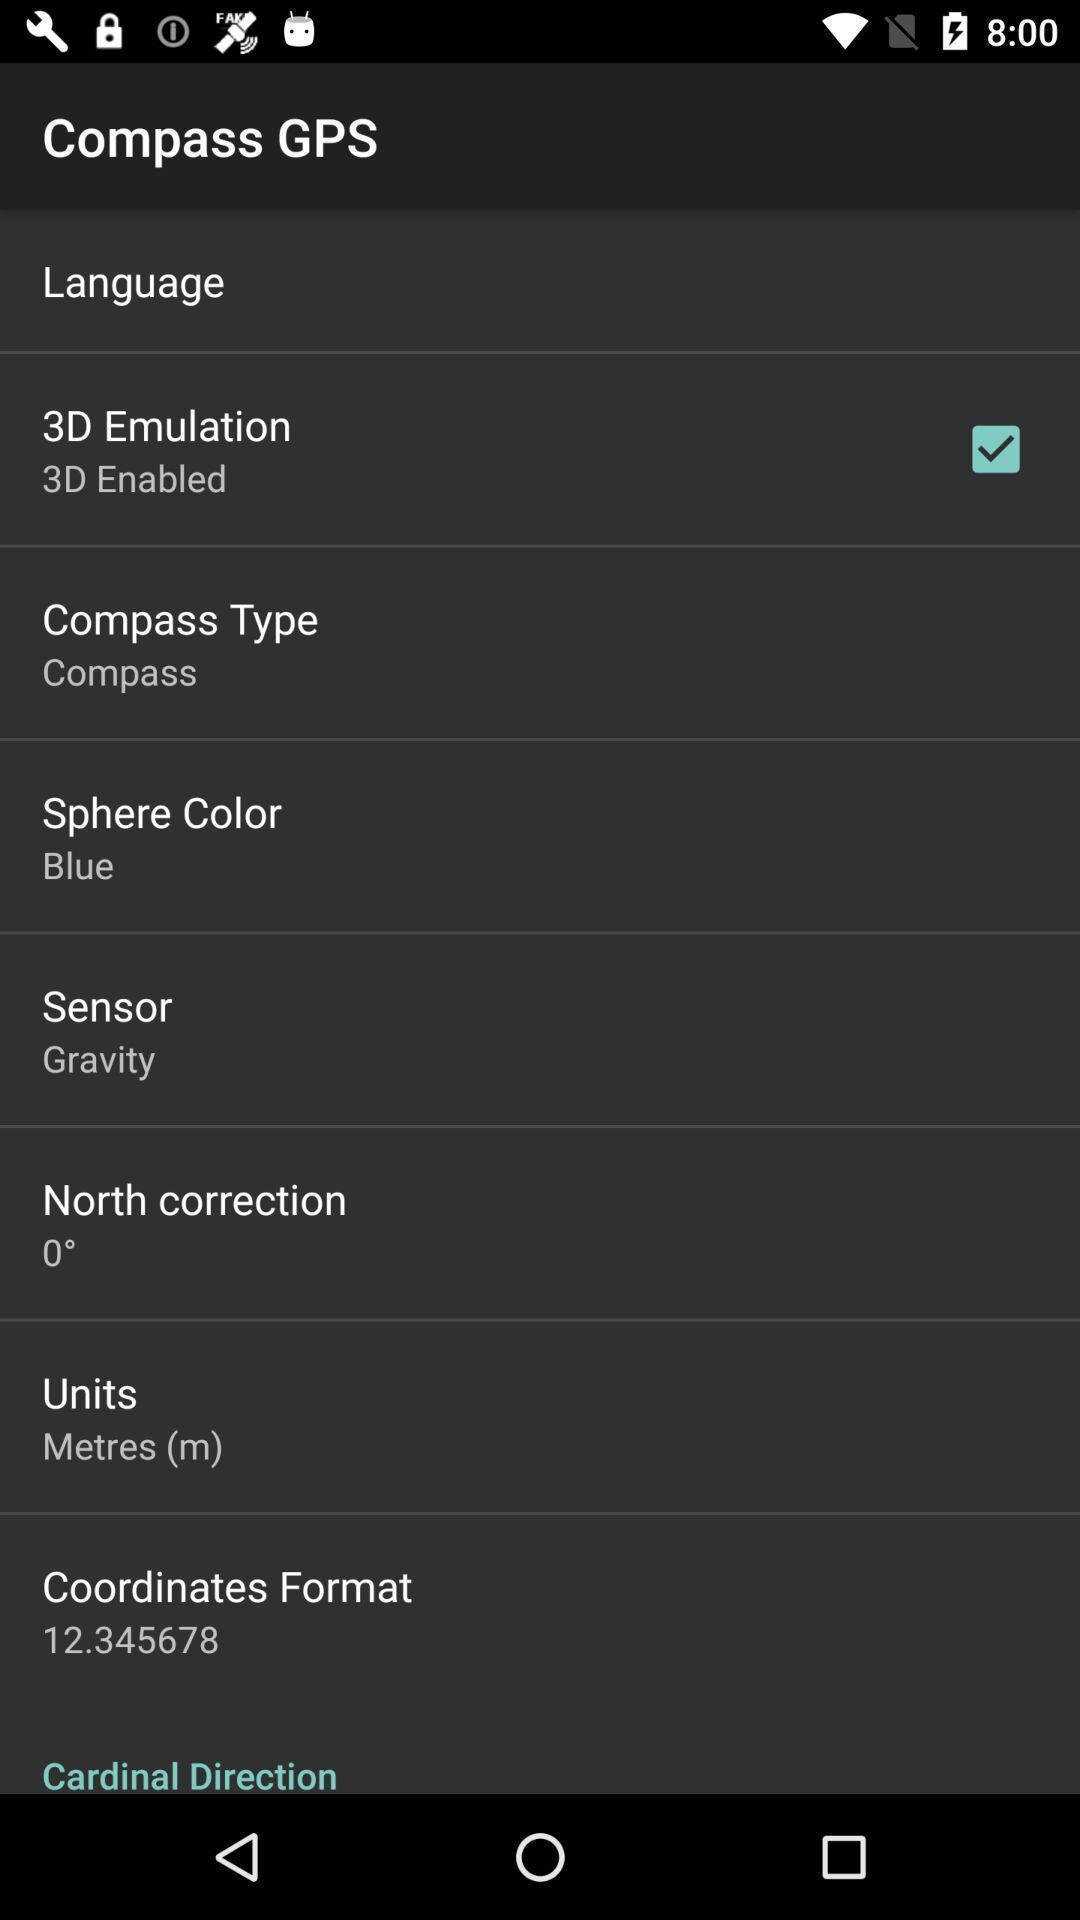Give me a summary of this screen capture. Page displaying various compass options. 